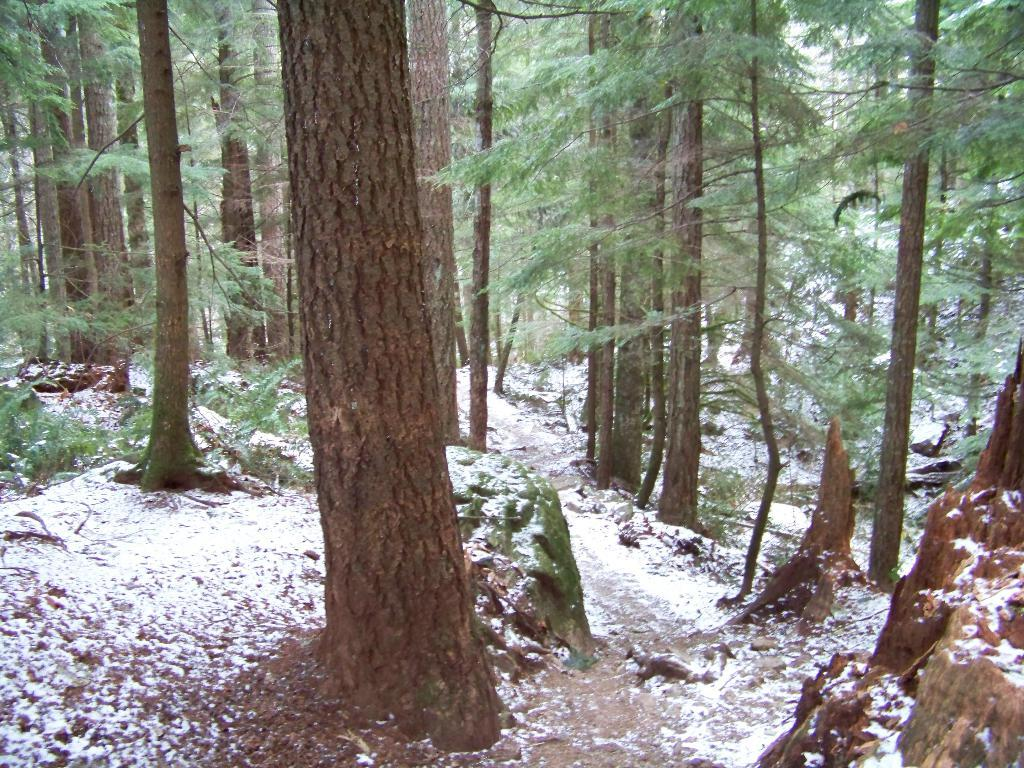What type of weather condition is depicted in the image? There is snow in the image. What natural elements can be seen in the image? There are trees in the image. What type of punishment is being carried out in the image? There is no punishment being carried out in the image; it only shows snow and trees. What type of river can be seen in the image? There is no river present in the image; it only shows snow and trees. 